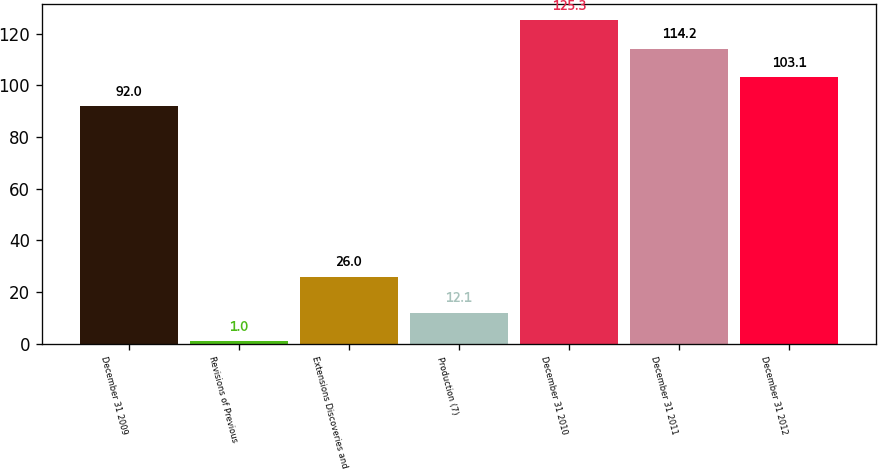<chart> <loc_0><loc_0><loc_500><loc_500><bar_chart><fcel>December 31 2009<fcel>Revisions of Previous<fcel>Extensions Discoveries and<fcel>Production (7)<fcel>December 31 2010<fcel>December 31 2011<fcel>December 31 2012<nl><fcel>92<fcel>1<fcel>26<fcel>12.1<fcel>125.3<fcel>114.2<fcel>103.1<nl></chart> 